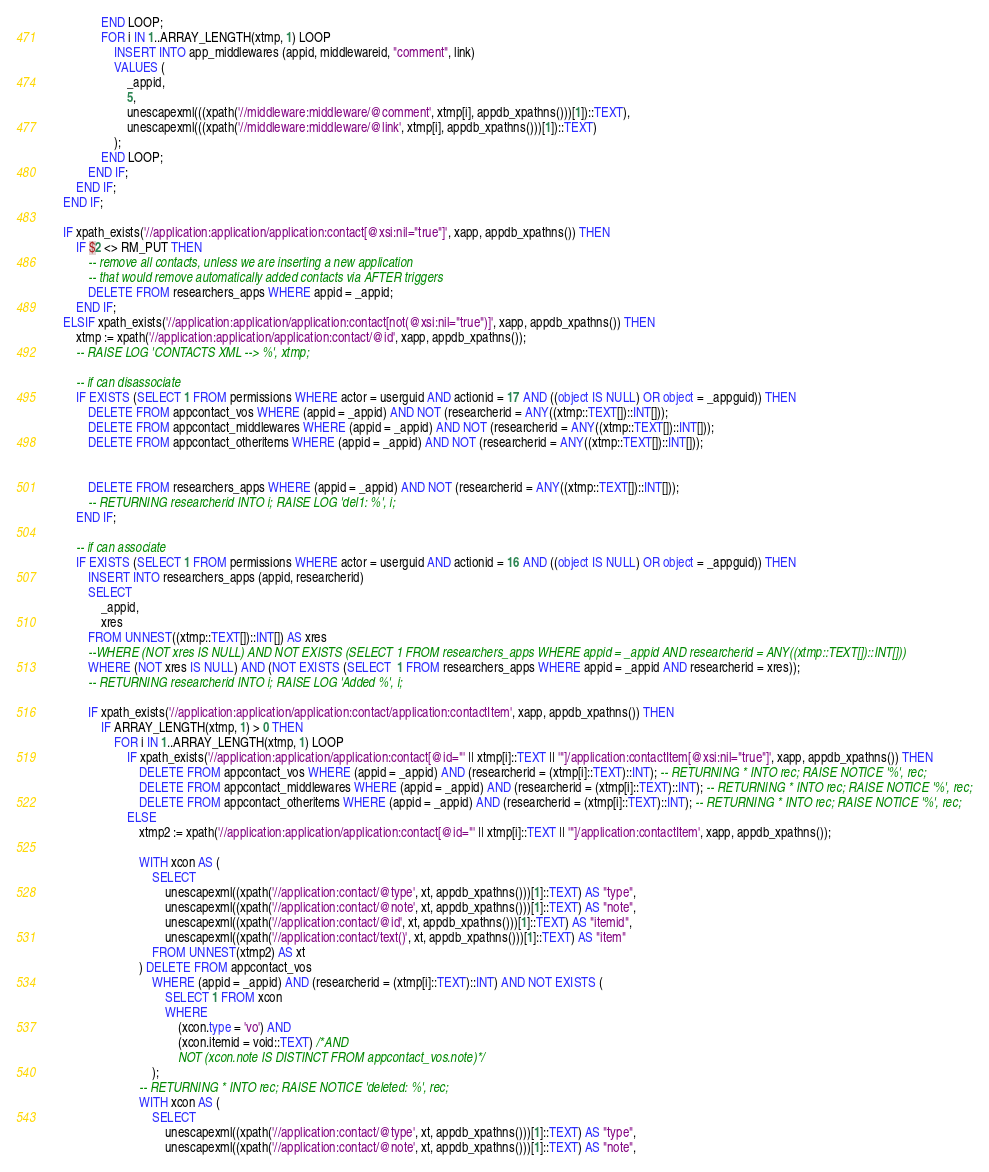Convert code to text. <code><loc_0><loc_0><loc_500><loc_500><_SQL_>				END LOOP;
				FOR i IN 1..ARRAY_LENGTH(xtmp, 1) LOOP
					INSERT INTO app_middlewares (appid, middlewareid, "comment", link)
					VALUES (
						_appid,
						5,
						unescapexml(((xpath('//middleware:middleware/@comment', xtmp[i], appdb_xpathns()))[1])::TEXT),
						unescapexml(((xpath('//middleware:middleware/@link', xtmp[i], appdb_xpathns()))[1])::TEXT)
					);
				END LOOP;
			END IF;
		END IF;
	END IF;

	IF xpath_exists('//application:application/application:contact[@xsi:nil="true"]', xapp, appdb_xpathns()) THEN
		IF $2 <> RM_PUT THEN
			-- remove all contacts, unless we are inserting a new application
			-- that would remove automatically added contacts via AFTER triggers
			DELETE FROM researchers_apps WHERE appid = _appid;
		END IF;
	ELSIF xpath_exists('//application:application/application:contact[not(@xsi:nil="true")]', xapp, appdb_xpathns()) THEN
		xtmp := xpath('//application:application/application:contact/@id', xapp, appdb_xpathns());
		-- RAISE LOG 'CONTACTS XML --> %', xtmp;

		-- if can disassociate
		IF EXISTS (SELECT 1 FROM permissions WHERE actor = userguid AND actionid = 17 AND ((object IS NULL) OR object = _appguid)) THEN
			DELETE FROM appcontact_vos WHERE (appid = _appid) AND NOT (researcherid = ANY((xtmp::TEXT[])::INT[]));
			DELETE FROM appcontact_middlewares WHERE (appid = _appid) AND NOT (researcherid = ANY((xtmp::TEXT[])::INT[]));
			DELETE FROM appcontact_otheritems WHERE (appid = _appid) AND NOT (researcherid = ANY((xtmp::TEXT[])::INT[]));


			DELETE FROM researchers_apps WHERE (appid = _appid) AND NOT (researcherid = ANY((xtmp::TEXT[])::INT[]));
			-- RETURNING researcherid INTO i; RAISE LOG 'del1: %', i;
		END IF;

		-- if can associate
		IF EXISTS (SELECT 1 FROM permissions WHERE actor = userguid AND actionid = 16 AND ((object IS NULL) OR object = _appguid)) THEN
			INSERT INTO researchers_apps (appid, researcherid)
			SELECT
				_appid,
				xres
			FROM UNNEST((xtmp::TEXT[])::INT[]) AS xres
			--WHERE (NOT xres IS NULL) AND NOT EXISTS (SELECT 1 FROM researchers_apps WHERE appid = _appid AND researcherid = ANY((xtmp::TEXT[])::INT[]))
			WHERE (NOT xres IS NULL) AND (NOT EXISTS (SELECT  1 FROM researchers_apps WHERE appid = _appid AND researcherid = xres));
			-- RETURNING researcherid INTO i; RAISE LOG 'Added %', i;

			IF xpath_exists('//application:application/application:contact/application:contactItem', xapp, appdb_xpathns()) THEN
				IF ARRAY_LENGTH(xtmp, 1) > 0 THEN
					FOR i IN 1..ARRAY_LENGTH(xtmp, 1) LOOP
						IF xpath_exists('//application:application/application:contact[@id="' || xtmp[i]::TEXT || '"]/application:contactItem[@xsi:nil="true"]', xapp, appdb_xpathns()) THEN
							DELETE FROM appcontact_vos WHERE (appid = _appid) AND (researcherid = (xtmp[i]::TEXT)::INT); -- RETURNING * INTO rec; RAISE NOTICE '%', rec;
							DELETE FROM appcontact_middlewares WHERE (appid = _appid) AND (researcherid = (xtmp[i]::TEXT)::INT); -- RETURNING * INTO rec; RAISE NOTICE '%', rec;
							DELETE FROM appcontact_otheritems WHERE (appid = _appid) AND (researcherid = (xtmp[i]::TEXT)::INT); -- RETURNING * INTO rec; RAISE NOTICE '%', rec;
						ELSE
							xtmp2 := xpath('//application:application/application:contact[@id="' || xtmp[i]::TEXT || '"]/application:contactItem', xapp, appdb_xpathns());

							WITH xcon AS (
								SELECT
									unescapexml((xpath('//application:contact/@type', xt, appdb_xpathns()))[1]::TEXT) AS "type",
									unescapexml((xpath('//application:contact/@note', xt, appdb_xpathns()))[1]::TEXT) AS "note",
									unescapexml((xpath('//application:contact/@id', xt, appdb_xpathns()))[1]::TEXT) AS "itemid",
									unescapexml((xpath('//application:contact/text()', xt, appdb_xpathns()))[1]::TEXT) AS "item"
								FROM UNNEST(xtmp2) AS xt
							) DELETE FROM appcontact_vos
								WHERE (appid = _appid) AND (researcherid = (xtmp[i]::TEXT)::INT) AND NOT EXISTS (
									SELECT 1 FROM xcon
									WHERE
										(xcon.type = 'vo') AND
										(xcon.itemid = void::TEXT) /*AND
										NOT (xcon.note IS DISTINCT FROM appcontact_vos.note)*/
								);
							-- RETURNING * INTO rec; RAISE NOTICE 'deleted: %', rec;
							WITH xcon AS (
								SELECT
									unescapexml((xpath('//application:contact/@type', xt, appdb_xpathns()))[1]::TEXT) AS "type",
									unescapexml((xpath('//application:contact/@note', xt, appdb_xpathns()))[1]::TEXT) AS "note",</code> 